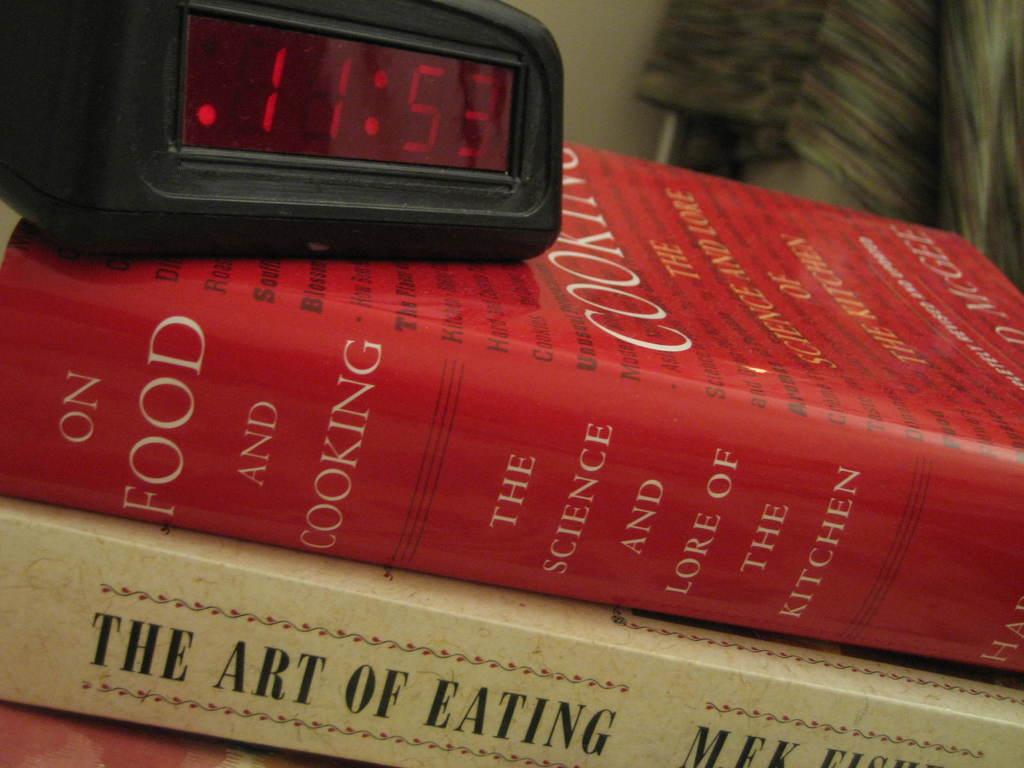What art is being discovered?
Provide a short and direct response. Eating. 